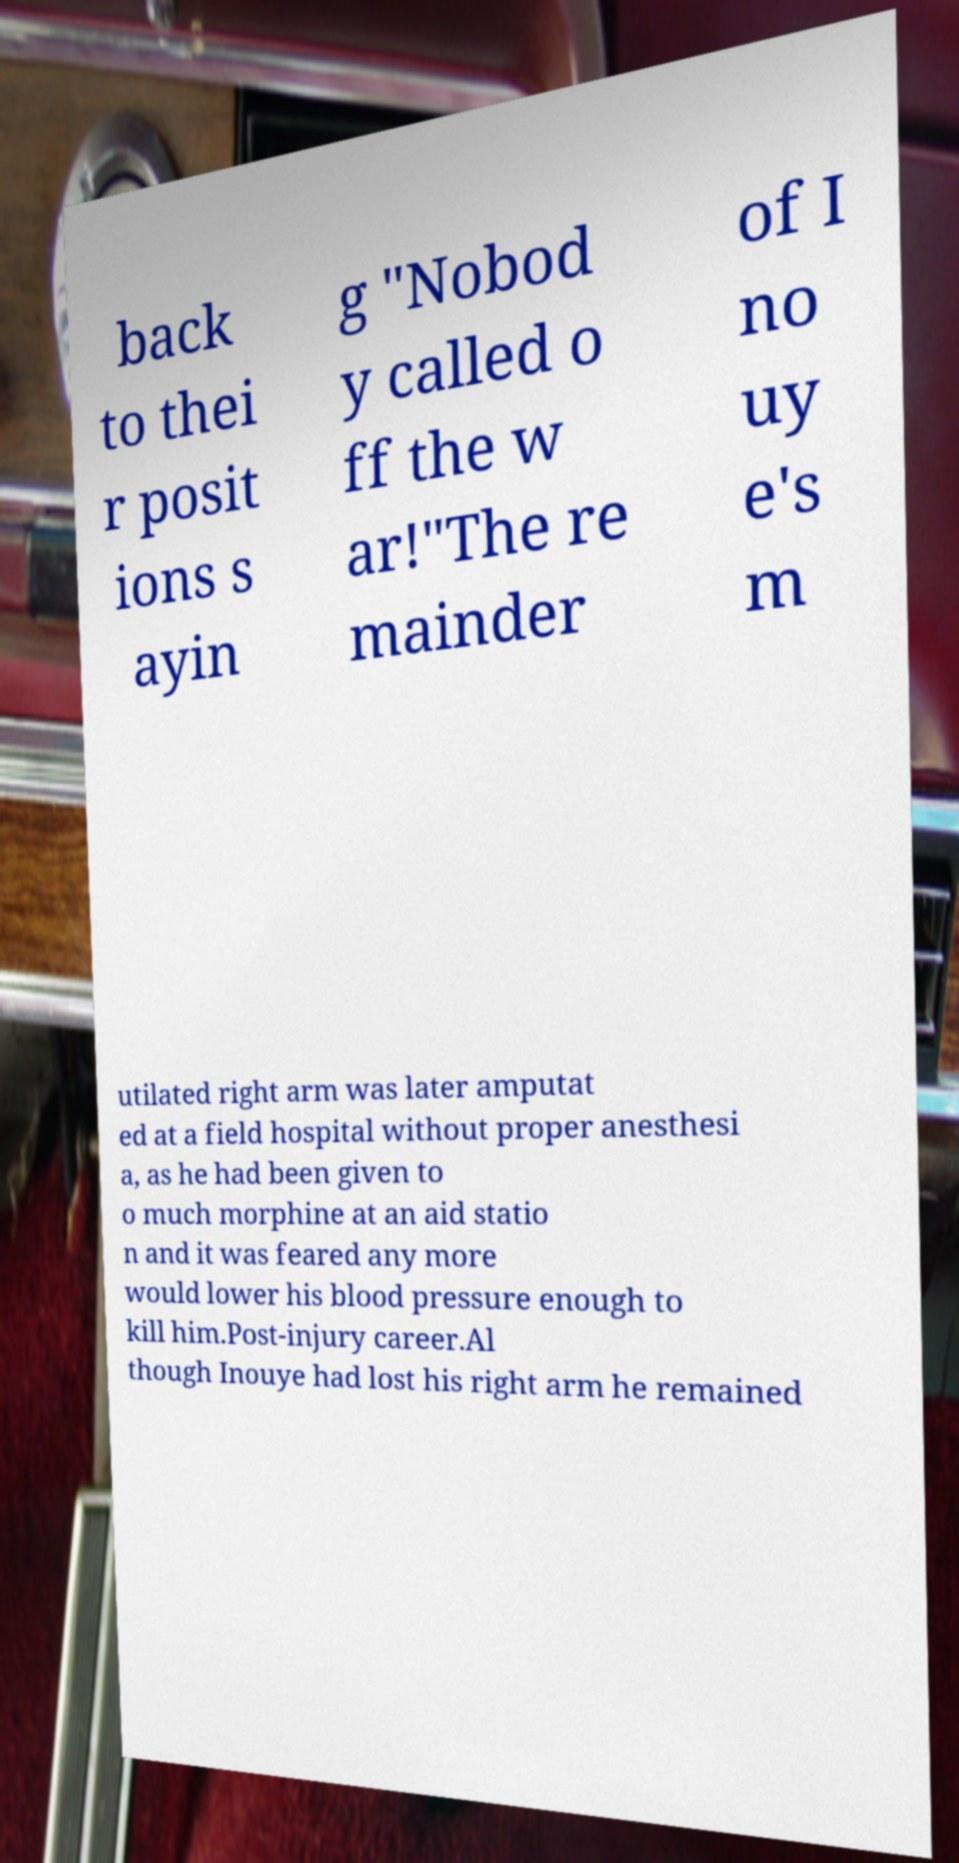Can you read and provide the text displayed in the image?This photo seems to have some interesting text. Can you extract and type it out for me? back to thei r posit ions s ayin g "Nobod y called o ff the w ar!"The re mainder of I no uy e's m utilated right arm was later amputat ed at a field hospital without proper anesthesi a, as he had been given to o much morphine at an aid statio n and it was feared any more would lower his blood pressure enough to kill him.Post-injury career.Al though Inouye had lost his right arm he remained 